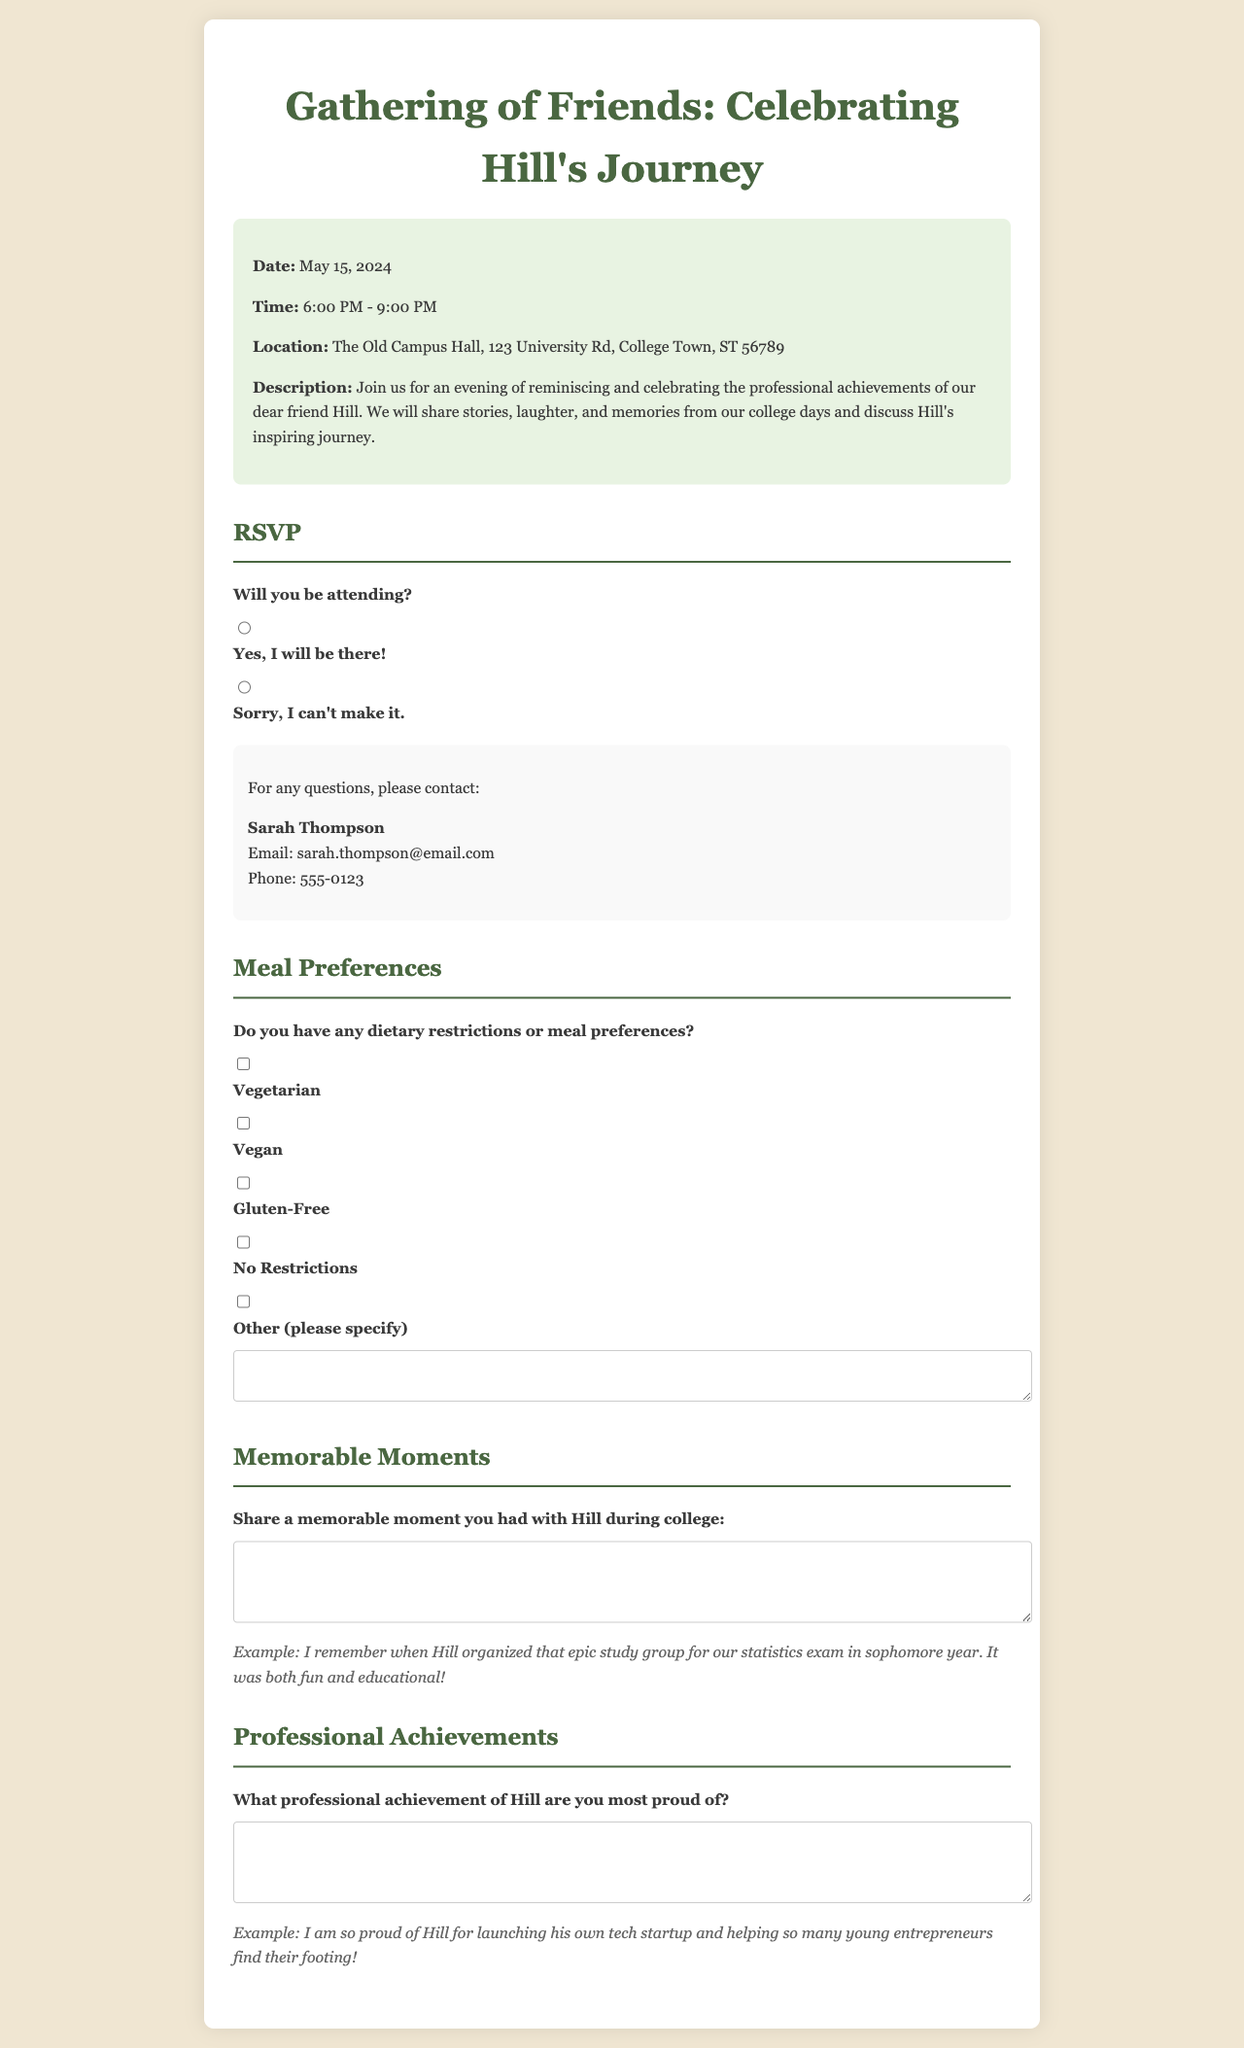What is the date of the gathering? The date of the gathering is mentioned clearly in the event details.
Answer: May 15, 2024 What is the venue for the event? The venue is specified in the event details section.
Answer: The Old Campus Hall What time does the gathering start? The start time is given under the event details section.
Answer: 6:00 PM Who should you contact for questions? The contact information is provided in the RSVP section.
Answer: Sarah Thompson What type of meal preference allows no restrictions? The meal preferences are listed with specific options.
Answer: No Restrictions Which dietary option is included for vegans? The dietary restrictions listed in the meal preferences include a specific option.
Answer: Vegan What memorable moment are attendees encouraged to share? The section prompts attendees to share a specific type of memory.
Answer: Memorable moment with Hill during college What professional achievement of Hill is requested to be shared? The form asks for a specific type of professional achievement related to Hill.
Answer: Professional achievement of Hill 